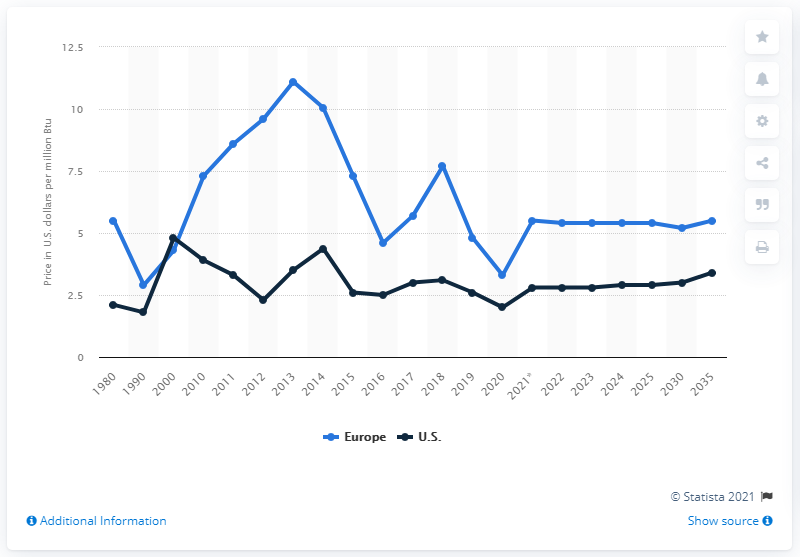List a handful of essential elements in this visual. The expected price of natural gas in Europe is projected to reach 5.5 by 2035. Since 1980, the prices of natural gas in Europe have consistently been higher than those in the United States. 